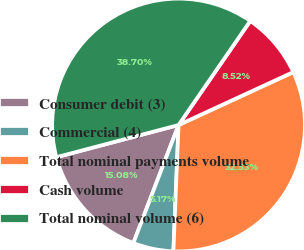<chart> <loc_0><loc_0><loc_500><loc_500><pie_chart><fcel>Consumer debit (3)<fcel>Commercial (4)<fcel>Total nominal payments volume<fcel>Cash volume<fcel>Total nominal volume (6)<nl><fcel>15.08%<fcel>5.17%<fcel>32.53%<fcel>8.52%<fcel>38.7%<nl></chart> 